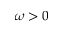<formula> <loc_0><loc_0><loc_500><loc_500>\omega > 0</formula> 